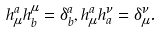Convert formula to latex. <formula><loc_0><loc_0><loc_500><loc_500>h _ { \mu } ^ { a } h _ { b } ^ { \mu } = \delta _ { b } ^ { a } , h _ { \mu } ^ { a } h _ { a } ^ { \nu } = \delta _ { \mu } ^ { \nu } .</formula> 